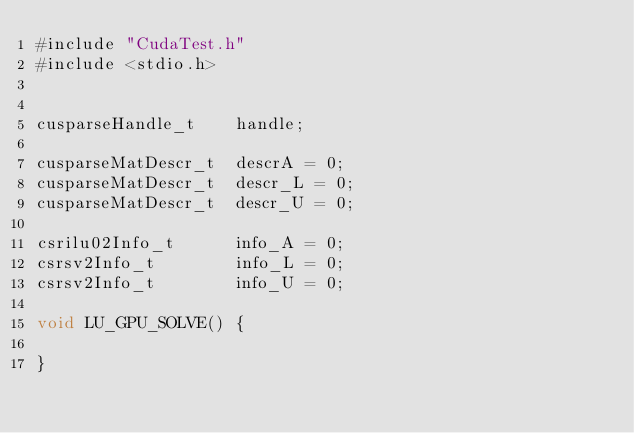<code> <loc_0><loc_0><loc_500><loc_500><_Cuda_>#include "CudaTest.h"
#include <stdio.h>


cusparseHandle_t    handle;

cusparseMatDescr_t  descrA = 0;
cusparseMatDescr_t  descr_L = 0;
cusparseMatDescr_t  descr_U = 0;

csrilu02Info_t      info_A = 0;
csrsv2Info_t        info_L = 0;
csrsv2Info_t        info_U = 0;

void LU_GPU_SOLVE() {

}
</code> 